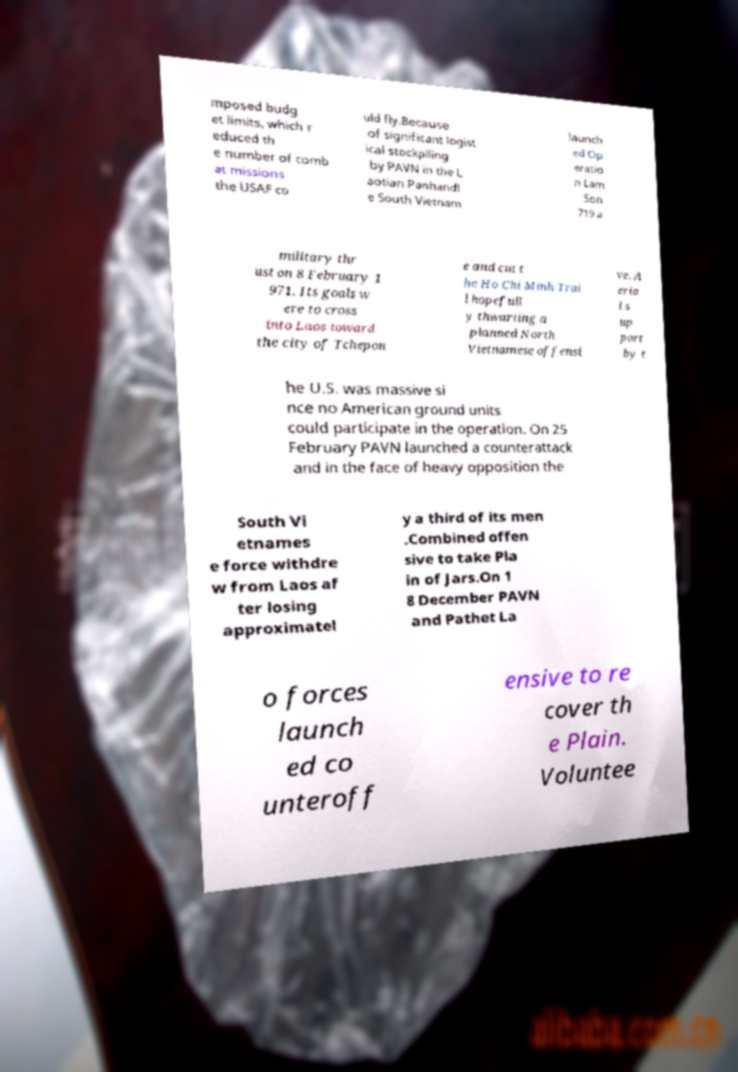There's text embedded in this image that I need extracted. Can you transcribe it verbatim? mposed budg et limits, which r educed th e number of comb at missions the USAF co uld fly.Because of significant logist ical stockpiling by PAVN in the L aotian Panhandl e South Vietnam launch ed Op eratio n Lam Son 719 a military thr ust on 8 February 1 971. Its goals w ere to cross into Laos toward the city of Tchepon e and cut t he Ho Chi Minh Trai l hopefull y thwarting a planned North Vietnamese offensi ve. A eria l s up port by t he U.S. was massive si nce no American ground units could participate in the operation. On 25 February PAVN launched a counterattack and in the face of heavy opposition the South Vi etnames e force withdre w from Laos af ter losing approximatel y a third of its men .Combined offen sive to take Pla in of Jars.On 1 8 December PAVN and Pathet La o forces launch ed co unteroff ensive to re cover th e Plain. Voluntee 